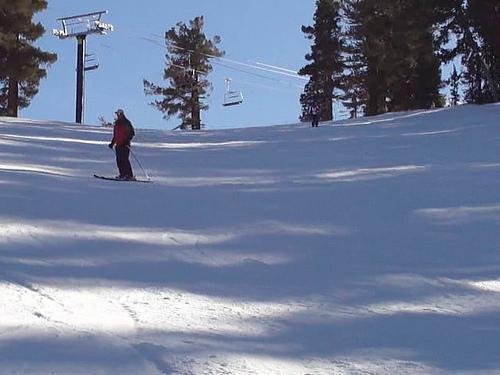How many people are shown?
Give a very brief answer. 2. 